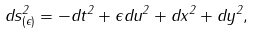<formula> <loc_0><loc_0><loc_500><loc_500>d s ^ { 2 } _ { ( \epsilon ) } = - d t ^ { 2 } + \epsilon d u ^ { 2 } + d x ^ { 2 } + d y ^ { 2 } ,</formula> 